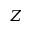<formula> <loc_0><loc_0><loc_500><loc_500>Z</formula> 